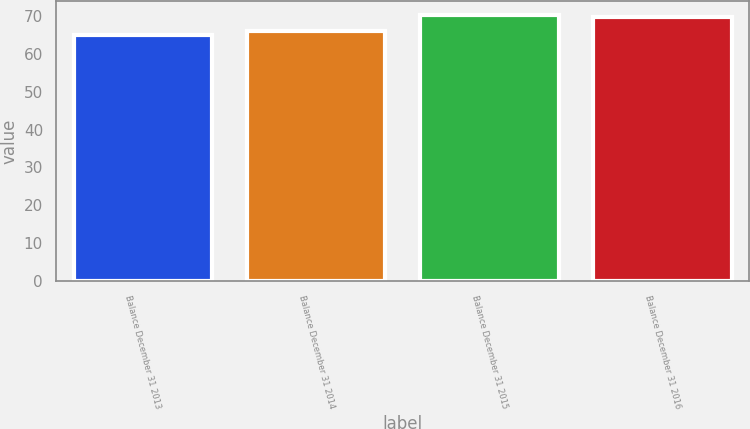Convert chart to OTSL. <chart><loc_0><loc_0><loc_500><loc_500><bar_chart><fcel>Balance December 31 2013<fcel>Balance December 31 2014<fcel>Balance December 31 2015<fcel>Balance December 31 2016<nl><fcel>65.1<fcel>66.2<fcel>70.5<fcel>69.8<nl></chart> 